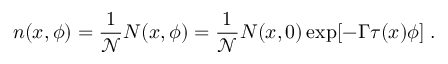<formula> <loc_0><loc_0><loc_500><loc_500>n ( x , \phi ) = \frac { 1 } { \mathcal { N } } N ( x , \phi ) = \frac { 1 } { \mathcal { N } } N ( x , 0 ) \exp [ - \Gamma \tau ( x ) \phi ] \, .</formula> 